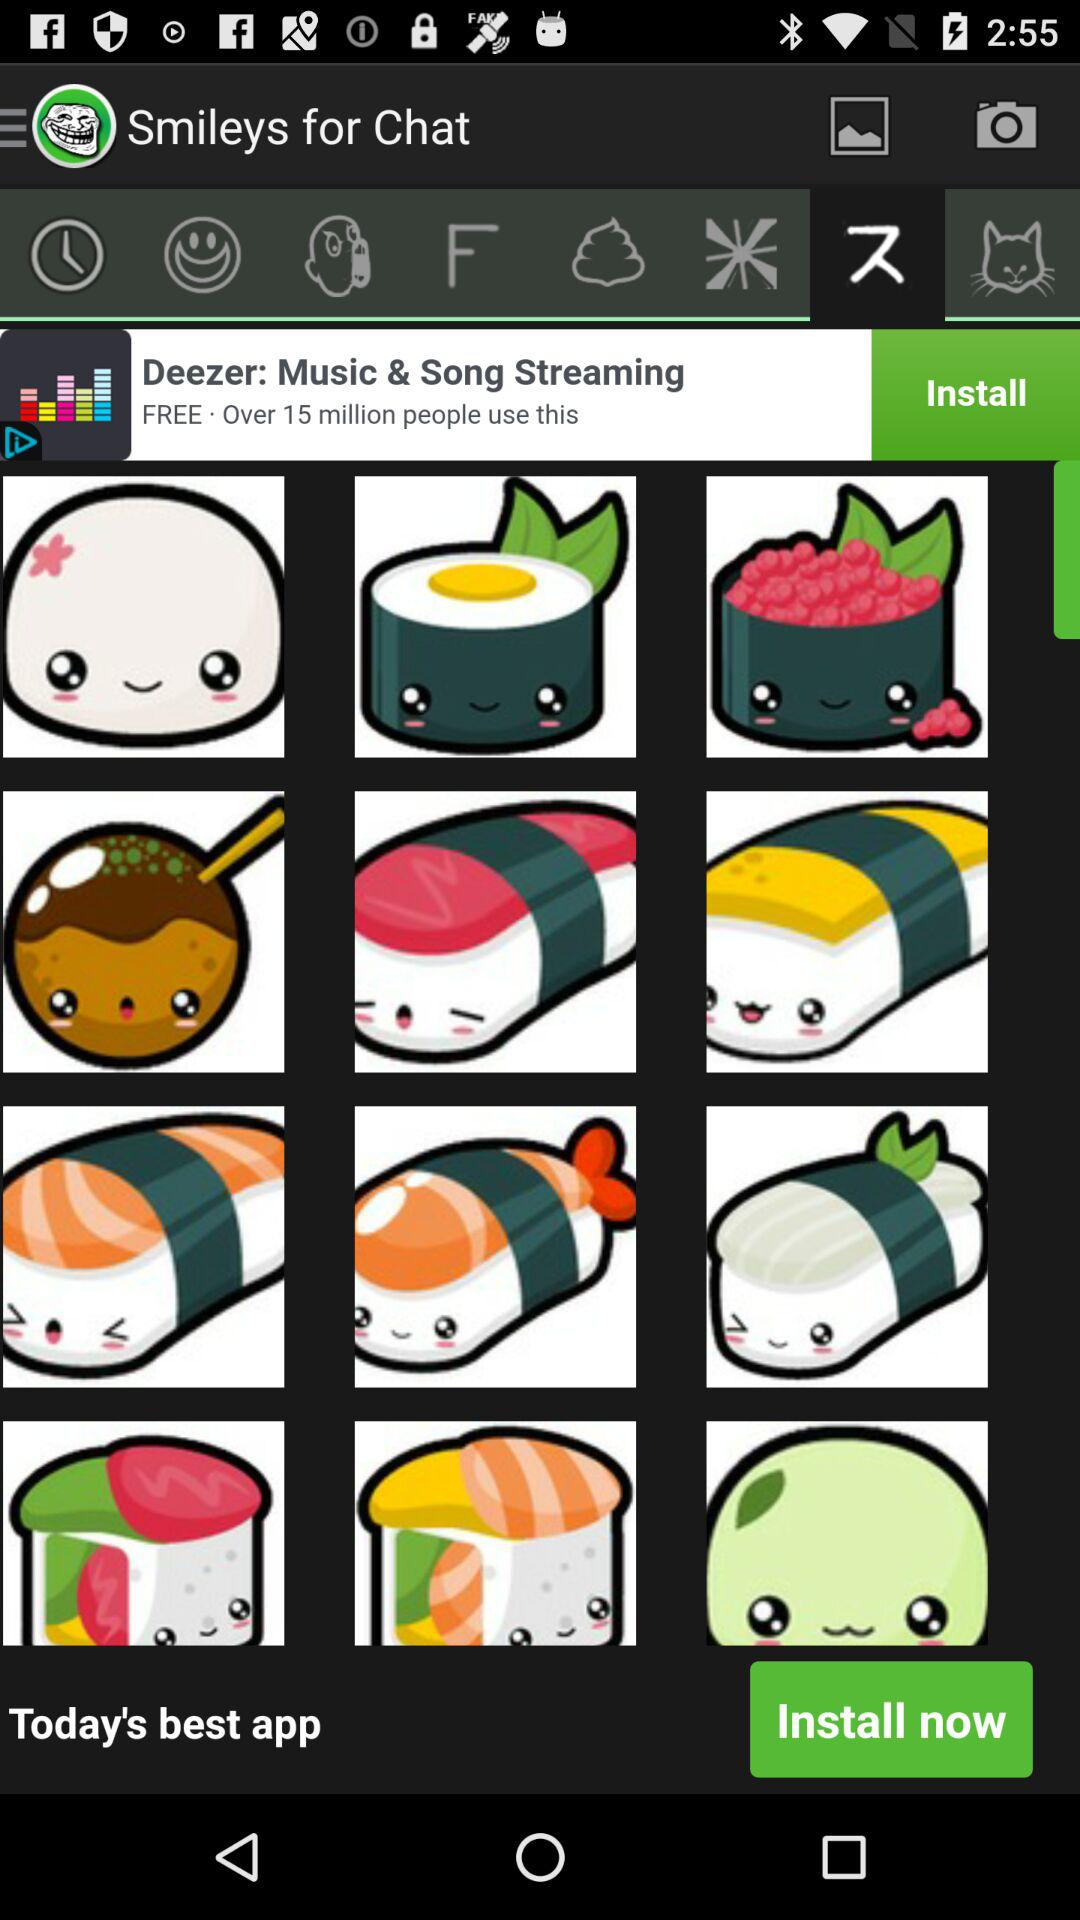What is the application name? The application name is "Smileys for Chat". 